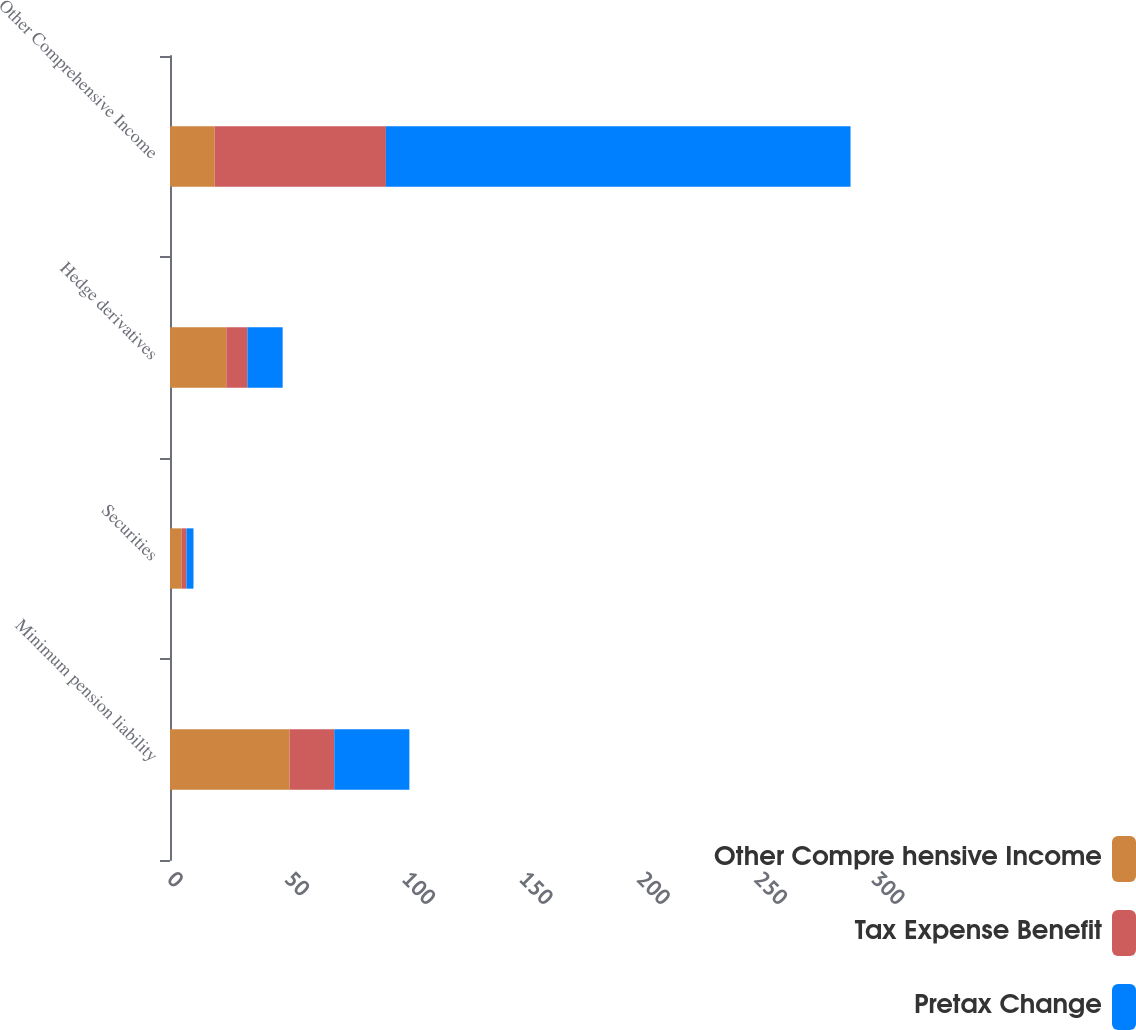Convert chart. <chart><loc_0><loc_0><loc_500><loc_500><stacked_bar_chart><ecel><fcel>Minimum pension liability<fcel>Securities<fcel>Hedge derivatives<fcel>Other Comprehensive Income<nl><fcel>Other Compre hensive Income<fcel>51<fcel>5<fcel>24<fcel>19<nl><fcel>Tax Expense Benefit<fcel>19<fcel>2<fcel>9<fcel>73<nl><fcel>Pretax Change<fcel>32<fcel>3<fcel>15<fcel>198<nl></chart> 